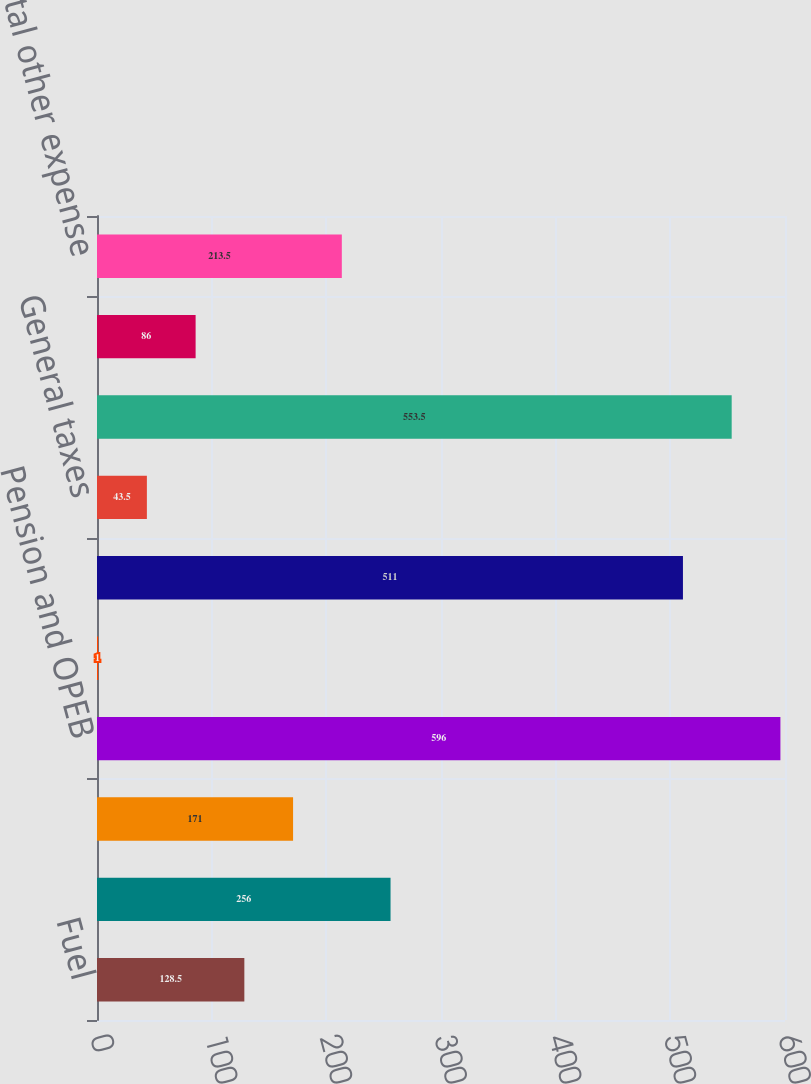<chart> <loc_0><loc_0><loc_500><loc_500><bar_chart><fcel>Fuel<fcel>Purchased power<fcel>Other operating expenses<fcel>Pension and OPEB<fcel>Provision for depreciation<fcel>Amortization of regulatory<fcel>General taxes<fcel>Investment income (loss)<fcel>Interest expense<fcel>Total other expense<nl><fcel>128.5<fcel>256<fcel>171<fcel>596<fcel>1<fcel>511<fcel>43.5<fcel>553.5<fcel>86<fcel>213.5<nl></chart> 